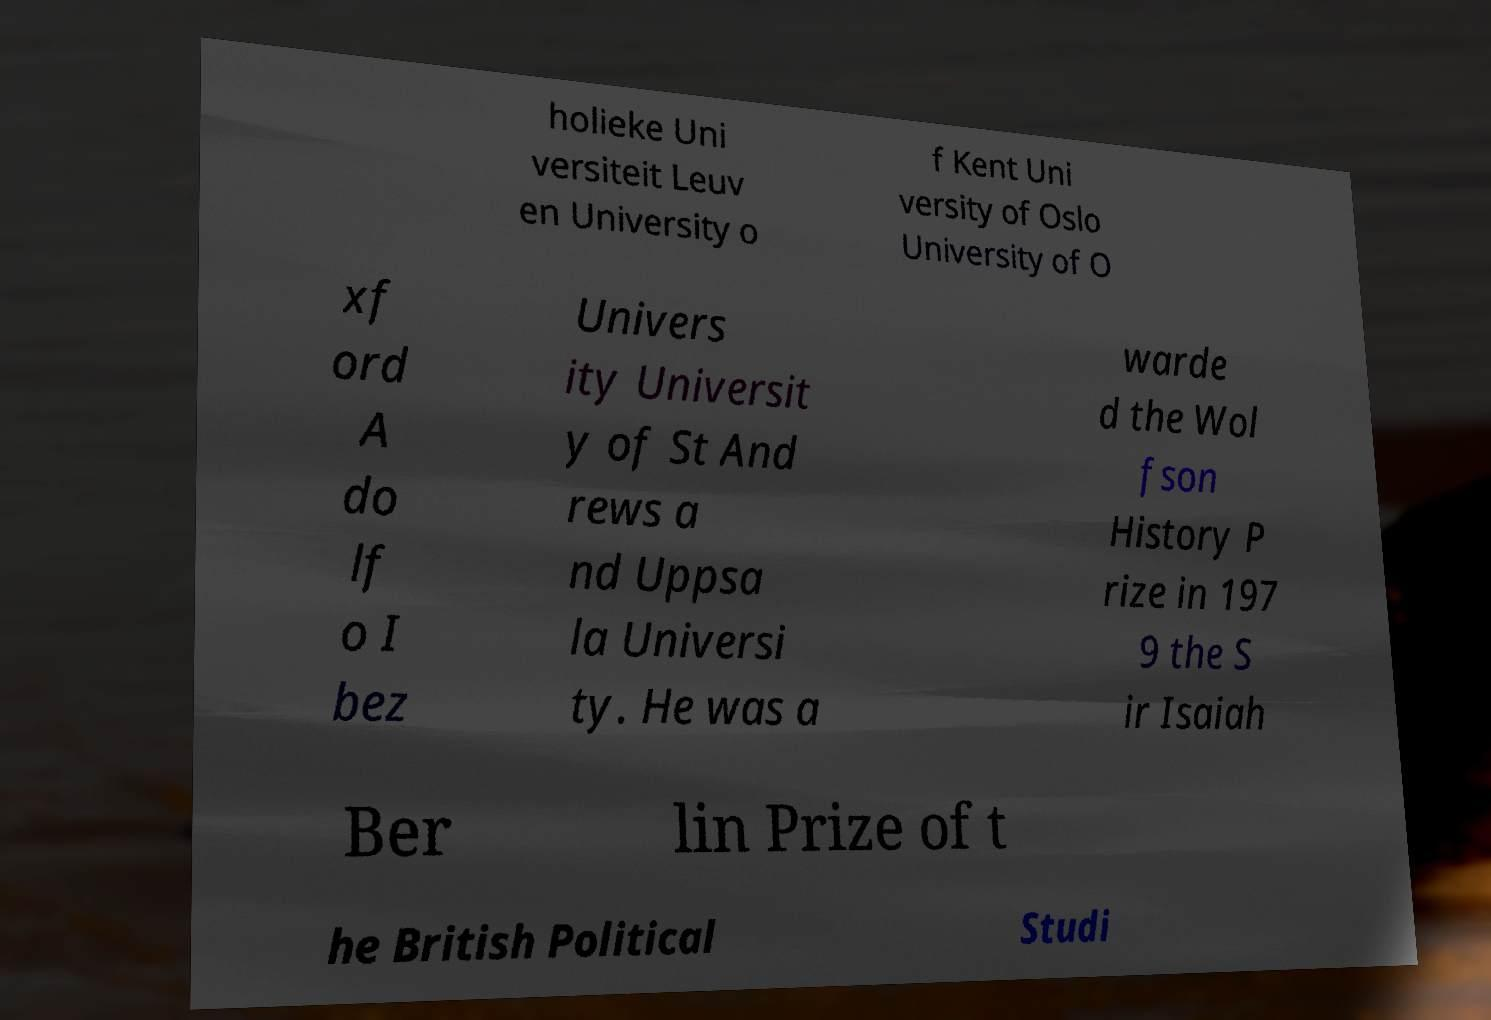Can you read and provide the text displayed in the image?This photo seems to have some interesting text. Can you extract and type it out for me? holieke Uni versiteit Leuv en University o f Kent Uni versity of Oslo University of O xf ord A do lf o I bez Univers ity Universit y of St And rews a nd Uppsa la Universi ty. He was a warde d the Wol fson History P rize in 197 9 the S ir Isaiah Ber lin Prize of t he British Political Studi 